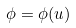<formula> <loc_0><loc_0><loc_500><loc_500>\phi = \phi ( u )</formula> 